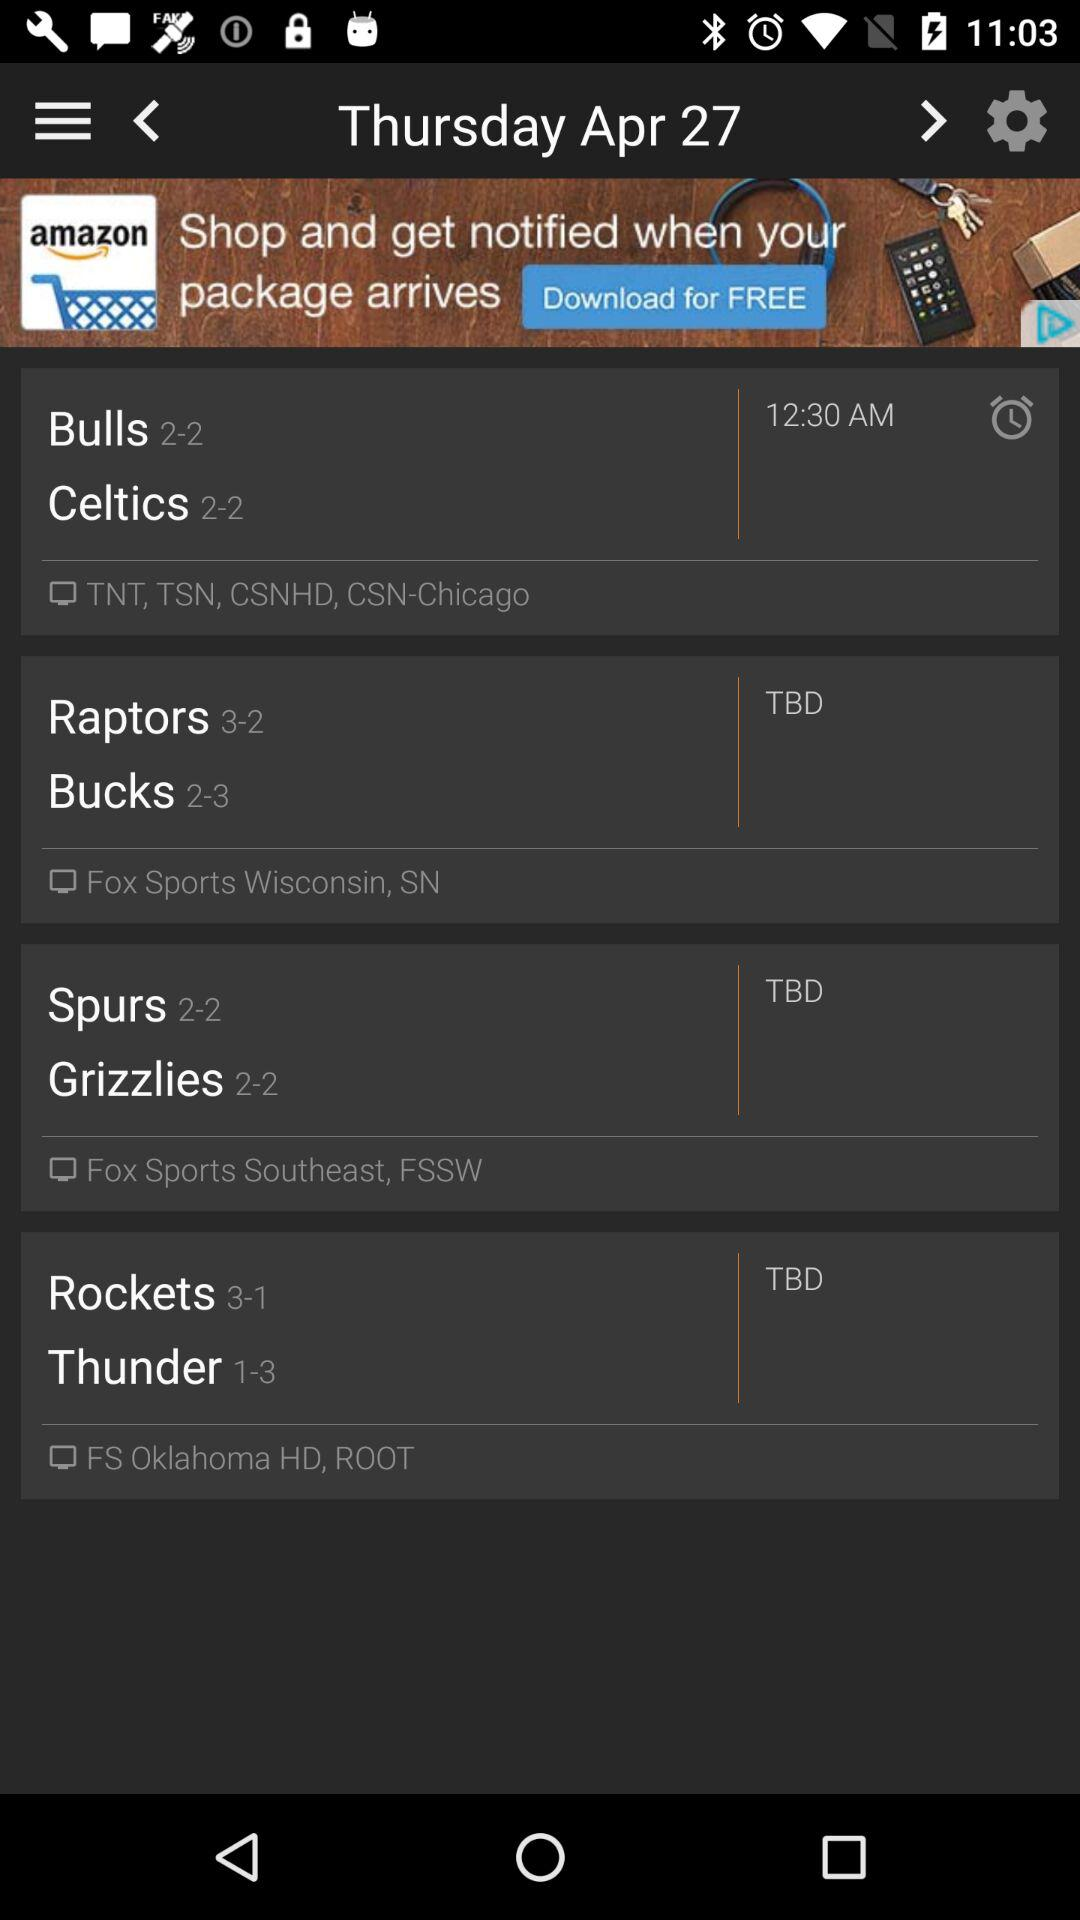What is the score of the Raptors? The score for the Raptors is 3-2. 